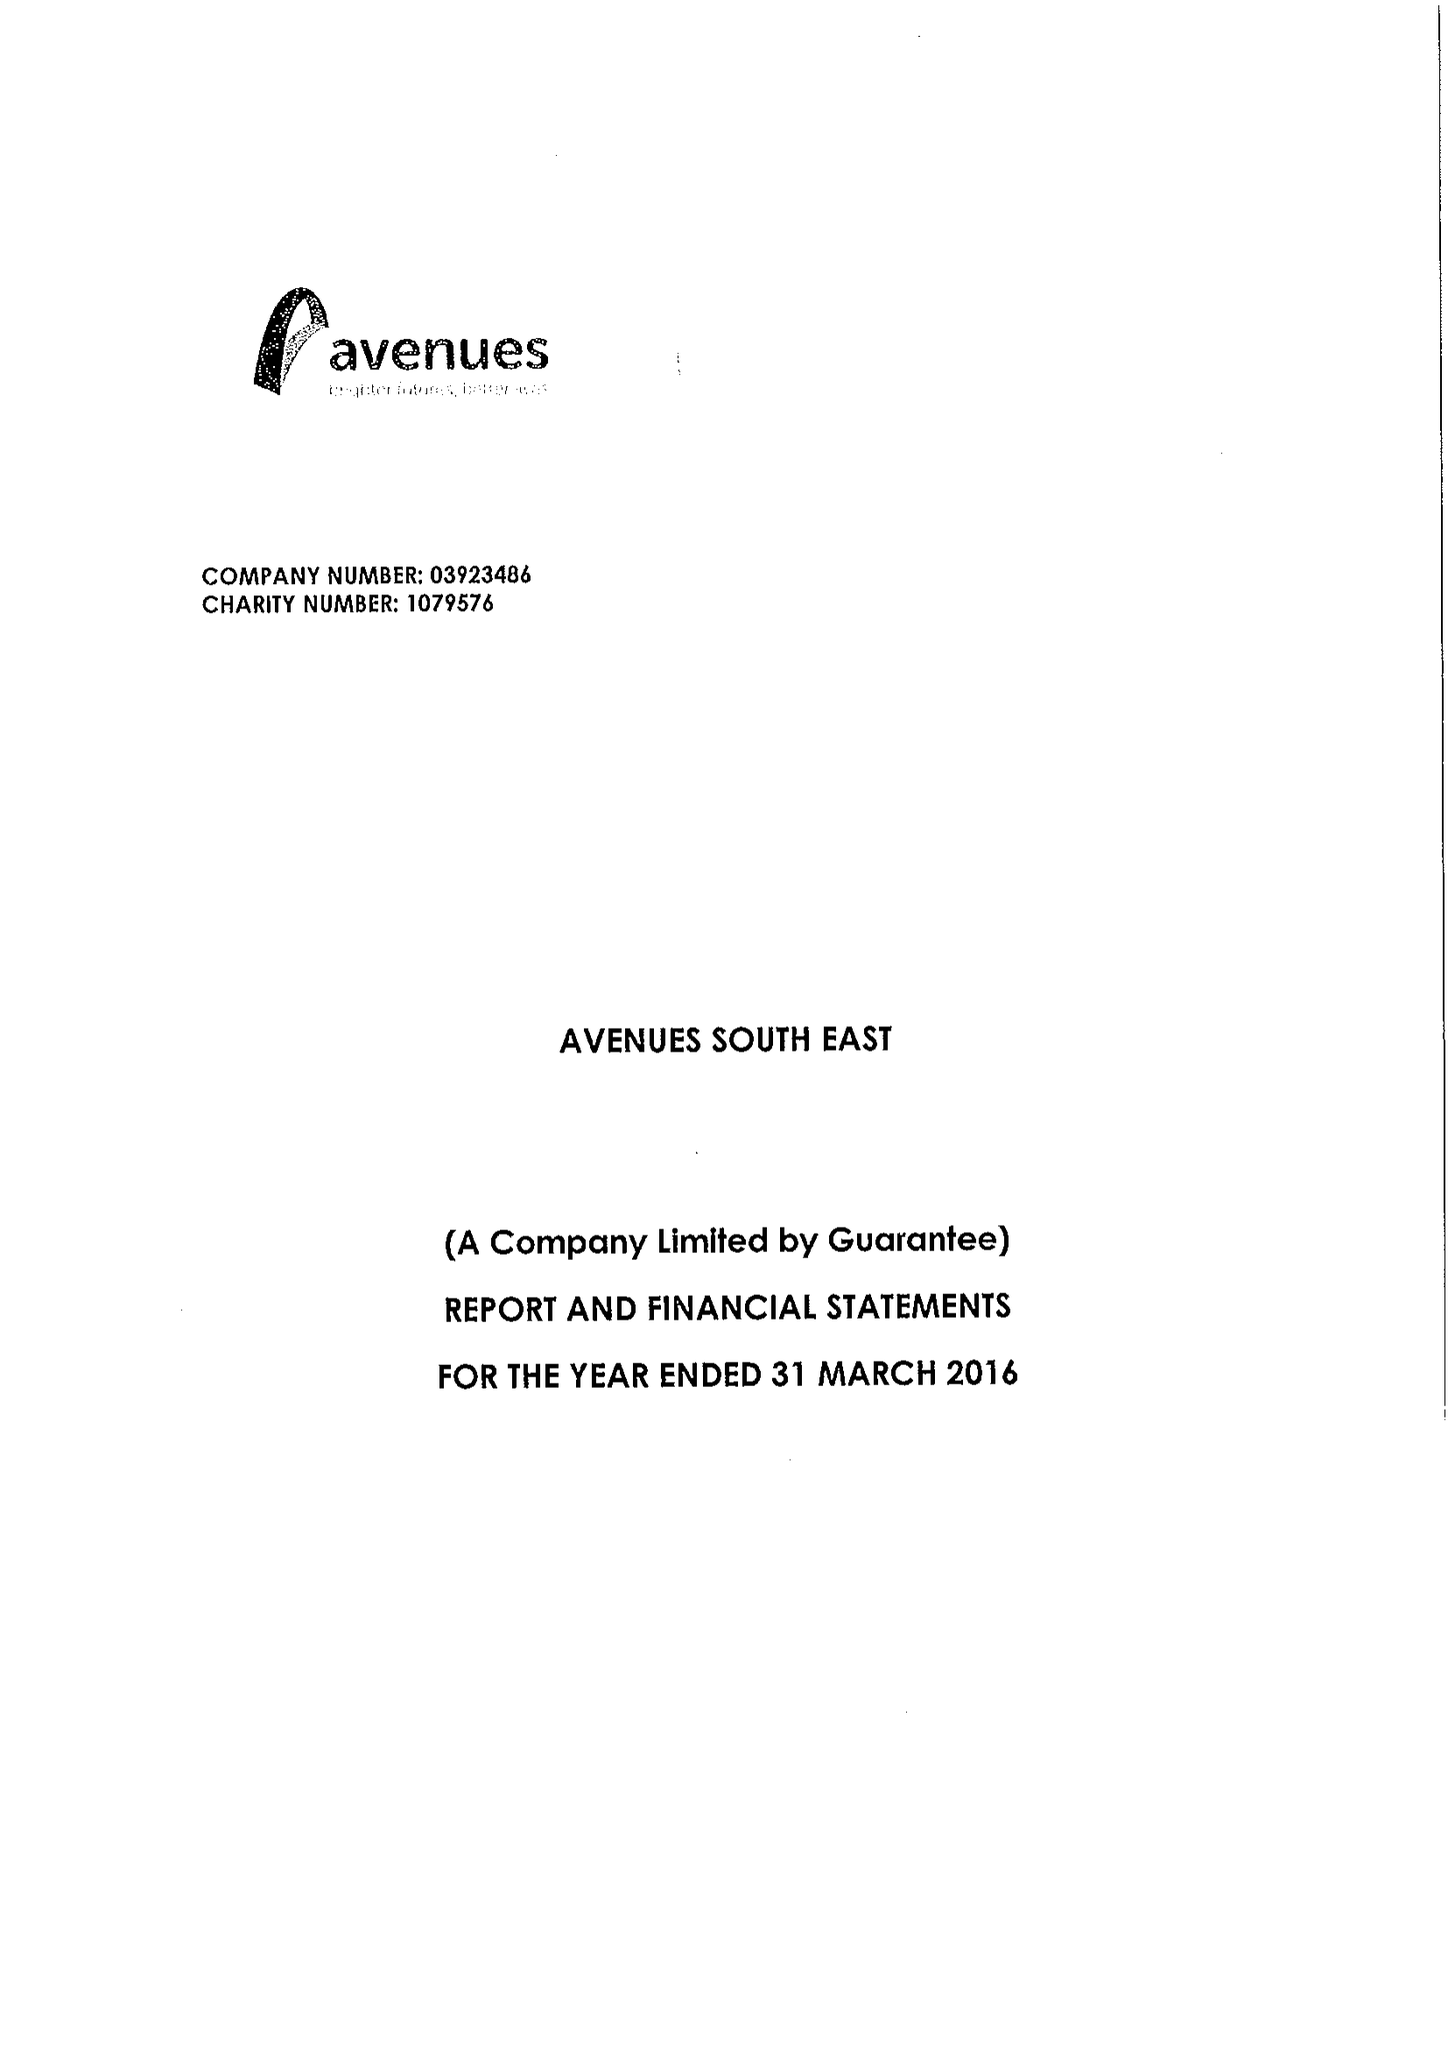What is the value for the address__street_line?
Answer the question using a single word or phrase. 1 MAIDSTONE ROAD 